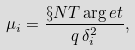<formula> <loc_0><loc_0><loc_500><loc_500>\mu _ { i } = \frac { \S N T \arg e t } { q \, \delta _ { i } ^ { 2 } } ,</formula> 